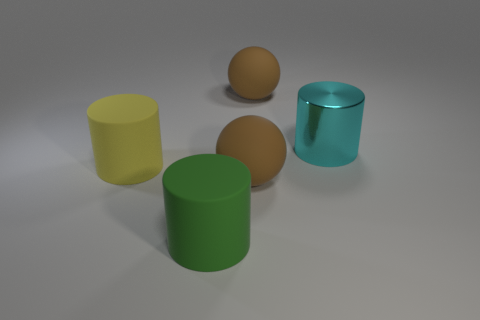Add 1 green rubber objects. How many objects exist? 6 Subtract all cylinders. How many objects are left? 2 Add 4 large metal objects. How many large metal objects exist? 5 Subtract 1 cyan cylinders. How many objects are left? 4 Subtract all large red metallic cubes. Subtract all matte cylinders. How many objects are left? 3 Add 5 large yellow objects. How many large yellow objects are left? 6 